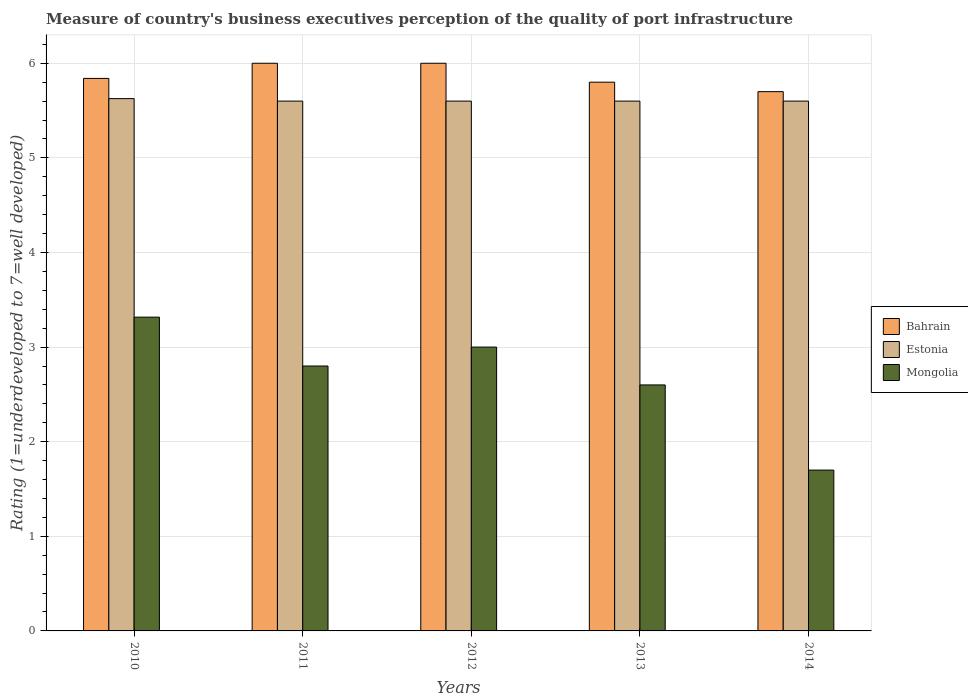How many different coloured bars are there?
Offer a very short reply. 3. How many groups of bars are there?
Keep it short and to the point. 5. Are the number of bars per tick equal to the number of legend labels?
Ensure brevity in your answer.  Yes. Are the number of bars on each tick of the X-axis equal?
Offer a very short reply. Yes. How many bars are there on the 2nd tick from the left?
Your answer should be compact. 3. How many bars are there on the 4th tick from the right?
Ensure brevity in your answer.  3. In how many cases, is the number of bars for a given year not equal to the number of legend labels?
Ensure brevity in your answer.  0. What is the ratings of the quality of port infrastructure in Bahrain in 2012?
Keep it short and to the point. 6. Across all years, what is the minimum ratings of the quality of port infrastructure in Bahrain?
Keep it short and to the point. 5.7. In which year was the ratings of the quality of port infrastructure in Estonia maximum?
Your response must be concise. 2010. What is the total ratings of the quality of port infrastructure in Mongolia in the graph?
Provide a short and direct response. 13.42. What is the difference between the ratings of the quality of port infrastructure in Estonia in 2010 and that in 2013?
Provide a short and direct response. 0.03. What is the difference between the ratings of the quality of port infrastructure in Mongolia in 2010 and the ratings of the quality of port infrastructure in Bahrain in 2012?
Provide a short and direct response. -2.68. What is the average ratings of the quality of port infrastructure in Bahrain per year?
Ensure brevity in your answer.  5.87. In the year 2011, what is the difference between the ratings of the quality of port infrastructure in Bahrain and ratings of the quality of port infrastructure in Mongolia?
Make the answer very short. 3.2. What is the ratio of the ratings of the quality of port infrastructure in Bahrain in 2011 to that in 2014?
Make the answer very short. 1.05. What is the difference between the highest and the second highest ratings of the quality of port infrastructure in Mongolia?
Offer a terse response. 0.32. What is the difference between the highest and the lowest ratings of the quality of port infrastructure in Mongolia?
Your answer should be very brief. 1.62. In how many years, is the ratings of the quality of port infrastructure in Estonia greater than the average ratings of the quality of port infrastructure in Estonia taken over all years?
Offer a terse response. 1. Is the sum of the ratings of the quality of port infrastructure in Mongolia in 2012 and 2013 greater than the maximum ratings of the quality of port infrastructure in Estonia across all years?
Give a very brief answer. No. What does the 1st bar from the left in 2011 represents?
Ensure brevity in your answer.  Bahrain. What does the 2nd bar from the right in 2013 represents?
Make the answer very short. Estonia. Is it the case that in every year, the sum of the ratings of the quality of port infrastructure in Mongolia and ratings of the quality of port infrastructure in Estonia is greater than the ratings of the quality of port infrastructure in Bahrain?
Offer a very short reply. Yes. How many bars are there?
Ensure brevity in your answer.  15. What is the difference between two consecutive major ticks on the Y-axis?
Your answer should be very brief. 1. Does the graph contain grids?
Provide a short and direct response. Yes. What is the title of the graph?
Your response must be concise. Measure of country's business executives perception of the quality of port infrastructure. What is the label or title of the X-axis?
Keep it short and to the point. Years. What is the label or title of the Y-axis?
Provide a succinct answer. Rating (1=underdeveloped to 7=well developed). What is the Rating (1=underdeveloped to 7=well developed) in Bahrain in 2010?
Give a very brief answer. 5.84. What is the Rating (1=underdeveloped to 7=well developed) in Estonia in 2010?
Provide a short and direct response. 5.63. What is the Rating (1=underdeveloped to 7=well developed) of Mongolia in 2010?
Your answer should be very brief. 3.32. What is the Rating (1=underdeveloped to 7=well developed) of Bahrain in 2011?
Provide a succinct answer. 6. What is the Rating (1=underdeveloped to 7=well developed) in Estonia in 2012?
Provide a short and direct response. 5.6. What is the Rating (1=underdeveloped to 7=well developed) of Mongolia in 2012?
Keep it short and to the point. 3. What is the Rating (1=underdeveloped to 7=well developed) in Mongolia in 2013?
Make the answer very short. 2.6. What is the Rating (1=underdeveloped to 7=well developed) in Mongolia in 2014?
Provide a succinct answer. 1.7. Across all years, what is the maximum Rating (1=underdeveloped to 7=well developed) of Estonia?
Your answer should be very brief. 5.63. Across all years, what is the maximum Rating (1=underdeveloped to 7=well developed) in Mongolia?
Ensure brevity in your answer.  3.32. Across all years, what is the minimum Rating (1=underdeveloped to 7=well developed) in Mongolia?
Provide a short and direct response. 1.7. What is the total Rating (1=underdeveloped to 7=well developed) of Bahrain in the graph?
Keep it short and to the point. 29.34. What is the total Rating (1=underdeveloped to 7=well developed) of Estonia in the graph?
Provide a succinct answer. 28.03. What is the total Rating (1=underdeveloped to 7=well developed) in Mongolia in the graph?
Keep it short and to the point. 13.42. What is the difference between the Rating (1=underdeveloped to 7=well developed) of Bahrain in 2010 and that in 2011?
Ensure brevity in your answer.  -0.16. What is the difference between the Rating (1=underdeveloped to 7=well developed) in Estonia in 2010 and that in 2011?
Keep it short and to the point. 0.03. What is the difference between the Rating (1=underdeveloped to 7=well developed) of Mongolia in 2010 and that in 2011?
Your response must be concise. 0.52. What is the difference between the Rating (1=underdeveloped to 7=well developed) of Bahrain in 2010 and that in 2012?
Your answer should be compact. -0.16. What is the difference between the Rating (1=underdeveloped to 7=well developed) of Estonia in 2010 and that in 2012?
Offer a terse response. 0.03. What is the difference between the Rating (1=underdeveloped to 7=well developed) in Mongolia in 2010 and that in 2012?
Give a very brief answer. 0.32. What is the difference between the Rating (1=underdeveloped to 7=well developed) in Bahrain in 2010 and that in 2013?
Your answer should be very brief. 0.04. What is the difference between the Rating (1=underdeveloped to 7=well developed) of Estonia in 2010 and that in 2013?
Your answer should be very brief. 0.03. What is the difference between the Rating (1=underdeveloped to 7=well developed) in Mongolia in 2010 and that in 2013?
Offer a terse response. 0.72. What is the difference between the Rating (1=underdeveloped to 7=well developed) of Bahrain in 2010 and that in 2014?
Provide a short and direct response. 0.14. What is the difference between the Rating (1=underdeveloped to 7=well developed) of Estonia in 2010 and that in 2014?
Offer a terse response. 0.03. What is the difference between the Rating (1=underdeveloped to 7=well developed) of Mongolia in 2010 and that in 2014?
Your response must be concise. 1.62. What is the difference between the Rating (1=underdeveloped to 7=well developed) in Estonia in 2011 and that in 2013?
Your answer should be very brief. 0. What is the difference between the Rating (1=underdeveloped to 7=well developed) of Estonia in 2011 and that in 2014?
Give a very brief answer. 0. What is the difference between the Rating (1=underdeveloped to 7=well developed) in Mongolia in 2011 and that in 2014?
Provide a short and direct response. 1.1. What is the difference between the Rating (1=underdeveloped to 7=well developed) in Estonia in 2012 and that in 2013?
Your answer should be compact. 0. What is the difference between the Rating (1=underdeveloped to 7=well developed) of Estonia in 2013 and that in 2014?
Give a very brief answer. 0. What is the difference between the Rating (1=underdeveloped to 7=well developed) in Mongolia in 2013 and that in 2014?
Your answer should be very brief. 0.9. What is the difference between the Rating (1=underdeveloped to 7=well developed) of Bahrain in 2010 and the Rating (1=underdeveloped to 7=well developed) of Estonia in 2011?
Offer a very short reply. 0.24. What is the difference between the Rating (1=underdeveloped to 7=well developed) of Bahrain in 2010 and the Rating (1=underdeveloped to 7=well developed) of Mongolia in 2011?
Offer a very short reply. 3.04. What is the difference between the Rating (1=underdeveloped to 7=well developed) of Estonia in 2010 and the Rating (1=underdeveloped to 7=well developed) of Mongolia in 2011?
Provide a short and direct response. 2.83. What is the difference between the Rating (1=underdeveloped to 7=well developed) of Bahrain in 2010 and the Rating (1=underdeveloped to 7=well developed) of Estonia in 2012?
Your answer should be very brief. 0.24. What is the difference between the Rating (1=underdeveloped to 7=well developed) in Bahrain in 2010 and the Rating (1=underdeveloped to 7=well developed) in Mongolia in 2012?
Offer a terse response. 2.84. What is the difference between the Rating (1=underdeveloped to 7=well developed) in Estonia in 2010 and the Rating (1=underdeveloped to 7=well developed) in Mongolia in 2012?
Your response must be concise. 2.63. What is the difference between the Rating (1=underdeveloped to 7=well developed) in Bahrain in 2010 and the Rating (1=underdeveloped to 7=well developed) in Estonia in 2013?
Your answer should be compact. 0.24. What is the difference between the Rating (1=underdeveloped to 7=well developed) of Bahrain in 2010 and the Rating (1=underdeveloped to 7=well developed) of Mongolia in 2013?
Your response must be concise. 3.24. What is the difference between the Rating (1=underdeveloped to 7=well developed) of Estonia in 2010 and the Rating (1=underdeveloped to 7=well developed) of Mongolia in 2013?
Provide a short and direct response. 3.03. What is the difference between the Rating (1=underdeveloped to 7=well developed) in Bahrain in 2010 and the Rating (1=underdeveloped to 7=well developed) in Estonia in 2014?
Keep it short and to the point. 0.24. What is the difference between the Rating (1=underdeveloped to 7=well developed) in Bahrain in 2010 and the Rating (1=underdeveloped to 7=well developed) in Mongolia in 2014?
Make the answer very short. 4.14. What is the difference between the Rating (1=underdeveloped to 7=well developed) in Estonia in 2010 and the Rating (1=underdeveloped to 7=well developed) in Mongolia in 2014?
Your response must be concise. 3.93. What is the difference between the Rating (1=underdeveloped to 7=well developed) of Bahrain in 2011 and the Rating (1=underdeveloped to 7=well developed) of Estonia in 2012?
Your answer should be very brief. 0.4. What is the difference between the Rating (1=underdeveloped to 7=well developed) of Bahrain in 2011 and the Rating (1=underdeveloped to 7=well developed) of Mongolia in 2012?
Ensure brevity in your answer.  3. What is the difference between the Rating (1=underdeveloped to 7=well developed) of Bahrain in 2011 and the Rating (1=underdeveloped to 7=well developed) of Estonia in 2013?
Your response must be concise. 0.4. What is the difference between the Rating (1=underdeveloped to 7=well developed) of Estonia in 2011 and the Rating (1=underdeveloped to 7=well developed) of Mongolia in 2013?
Provide a short and direct response. 3. What is the difference between the Rating (1=underdeveloped to 7=well developed) in Bahrain in 2011 and the Rating (1=underdeveloped to 7=well developed) in Estonia in 2014?
Your answer should be compact. 0.4. What is the difference between the Rating (1=underdeveloped to 7=well developed) in Estonia in 2012 and the Rating (1=underdeveloped to 7=well developed) in Mongolia in 2013?
Make the answer very short. 3. What is the difference between the Rating (1=underdeveloped to 7=well developed) of Bahrain in 2013 and the Rating (1=underdeveloped to 7=well developed) of Estonia in 2014?
Offer a terse response. 0.2. What is the average Rating (1=underdeveloped to 7=well developed) of Bahrain per year?
Keep it short and to the point. 5.87. What is the average Rating (1=underdeveloped to 7=well developed) of Estonia per year?
Your response must be concise. 5.61. What is the average Rating (1=underdeveloped to 7=well developed) of Mongolia per year?
Your response must be concise. 2.68. In the year 2010, what is the difference between the Rating (1=underdeveloped to 7=well developed) of Bahrain and Rating (1=underdeveloped to 7=well developed) of Estonia?
Offer a terse response. 0.21. In the year 2010, what is the difference between the Rating (1=underdeveloped to 7=well developed) of Bahrain and Rating (1=underdeveloped to 7=well developed) of Mongolia?
Keep it short and to the point. 2.52. In the year 2010, what is the difference between the Rating (1=underdeveloped to 7=well developed) of Estonia and Rating (1=underdeveloped to 7=well developed) of Mongolia?
Your answer should be very brief. 2.31. In the year 2011, what is the difference between the Rating (1=underdeveloped to 7=well developed) of Bahrain and Rating (1=underdeveloped to 7=well developed) of Mongolia?
Your answer should be compact. 3.2. In the year 2013, what is the difference between the Rating (1=underdeveloped to 7=well developed) of Bahrain and Rating (1=underdeveloped to 7=well developed) of Mongolia?
Ensure brevity in your answer.  3.2. In the year 2014, what is the difference between the Rating (1=underdeveloped to 7=well developed) in Bahrain and Rating (1=underdeveloped to 7=well developed) in Estonia?
Keep it short and to the point. 0.1. In the year 2014, what is the difference between the Rating (1=underdeveloped to 7=well developed) of Bahrain and Rating (1=underdeveloped to 7=well developed) of Mongolia?
Your answer should be compact. 4. In the year 2014, what is the difference between the Rating (1=underdeveloped to 7=well developed) of Estonia and Rating (1=underdeveloped to 7=well developed) of Mongolia?
Provide a short and direct response. 3.9. What is the ratio of the Rating (1=underdeveloped to 7=well developed) of Bahrain in 2010 to that in 2011?
Offer a very short reply. 0.97. What is the ratio of the Rating (1=underdeveloped to 7=well developed) of Mongolia in 2010 to that in 2011?
Provide a succinct answer. 1.18. What is the ratio of the Rating (1=underdeveloped to 7=well developed) in Bahrain in 2010 to that in 2012?
Provide a short and direct response. 0.97. What is the ratio of the Rating (1=underdeveloped to 7=well developed) in Estonia in 2010 to that in 2012?
Your answer should be very brief. 1. What is the ratio of the Rating (1=underdeveloped to 7=well developed) in Mongolia in 2010 to that in 2012?
Offer a very short reply. 1.11. What is the ratio of the Rating (1=underdeveloped to 7=well developed) of Bahrain in 2010 to that in 2013?
Give a very brief answer. 1.01. What is the ratio of the Rating (1=underdeveloped to 7=well developed) of Estonia in 2010 to that in 2013?
Provide a succinct answer. 1. What is the ratio of the Rating (1=underdeveloped to 7=well developed) of Mongolia in 2010 to that in 2013?
Keep it short and to the point. 1.28. What is the ratio of the Rating (1=underdeveloped to 7=well developed) of Bahrain in 2010 to that in 2014?
Your answer should be very brief. 1.02. What is the ratio of the Rating (1=underdeveloped to 7=well developed) in Mongolia in 2010 to that in 2014?
Your answer should be compact. 1.95. What is the ratio of the Rating (1=underdeveloped to 7=well developed) in Bahrain in 2011 to that in 2012?
Keep it short and to the point. 1. What is the ratio of the Rating (1=underdeveloped to 7=well developed) of Bahrain in 2011 to that in 2013?
Give a very brief answer. 1.03. What is the ratio of the Rating (1=underdeveloped to 7=well developed) in Bahrain in 2011 to that in 2014?
Give a very brief answer. 1.05. What is the ratio of the Rating (1=underdeveloped to 7=well developed) of Mongolia in 2011 to that in 2014?
Make the answer very short. 1.65. What is the ratio of the Rating (1=underdeveloped to 7=well developed) in Bahrain in 2012 to that in 2013?
Offer a terse response. 1.03. What is the ratio of the Rating (1=underdeveloped to 7=well developed) in Mongolia in 2012 to that in 2013?
Your answer should be compact. 1.15. What is the ratio of the Rating (1=underdeveloped to 7=well developed) in Bahrain in 2012 to that in 2014?
Provide a short and direct response. 1.05. What is the ratio of the Rating (1=underdeveloped to 7=well developed) of Mongolia in 2012 to that in 2014?
Keep it short and to the point. 1.76. What is the ratio of the Rating (1=underdeveloped to 7=well developed) of Bahrain in 2013 to that in 2014?
Your response must be concise. 1.02. What is the ratio of the Rating (1=underdeveloped to 7=well developed) in Mongolia in 2013 to that in 2014?
Keep it short and to the point. 1.53. What is the difference between the highest and the second highest Rating (1=underdeveloped to 7=well developed) in Bahrain?
Your answer should be very brief. 0. What is the difference between the highest and the second highest Rating (1=underdeveloped to 7=well developed) of Estonia?
Your answer should be compact. 0.03. What is the difference between the highest and the second highest Rating (1=underdeveloped to 7=well developed) of Mongolia?
Offer a terse response. 0.32. What is the difference between the highest and the lowest Rating (1=underdeveloped to 7=well developed) of Bahrain?
Provide a succinct answer. 0.3. What is the difference between the highest and the lowest Rating (1=underdeveloped to 7=well developed) of Estonia?
Give a very brief answer. 0.03. What is the difference between the highest and the lowest Rating (1=underdeveloped to 7=well developed) of Mongolia?
Keep it short and to the point. 1.62. 